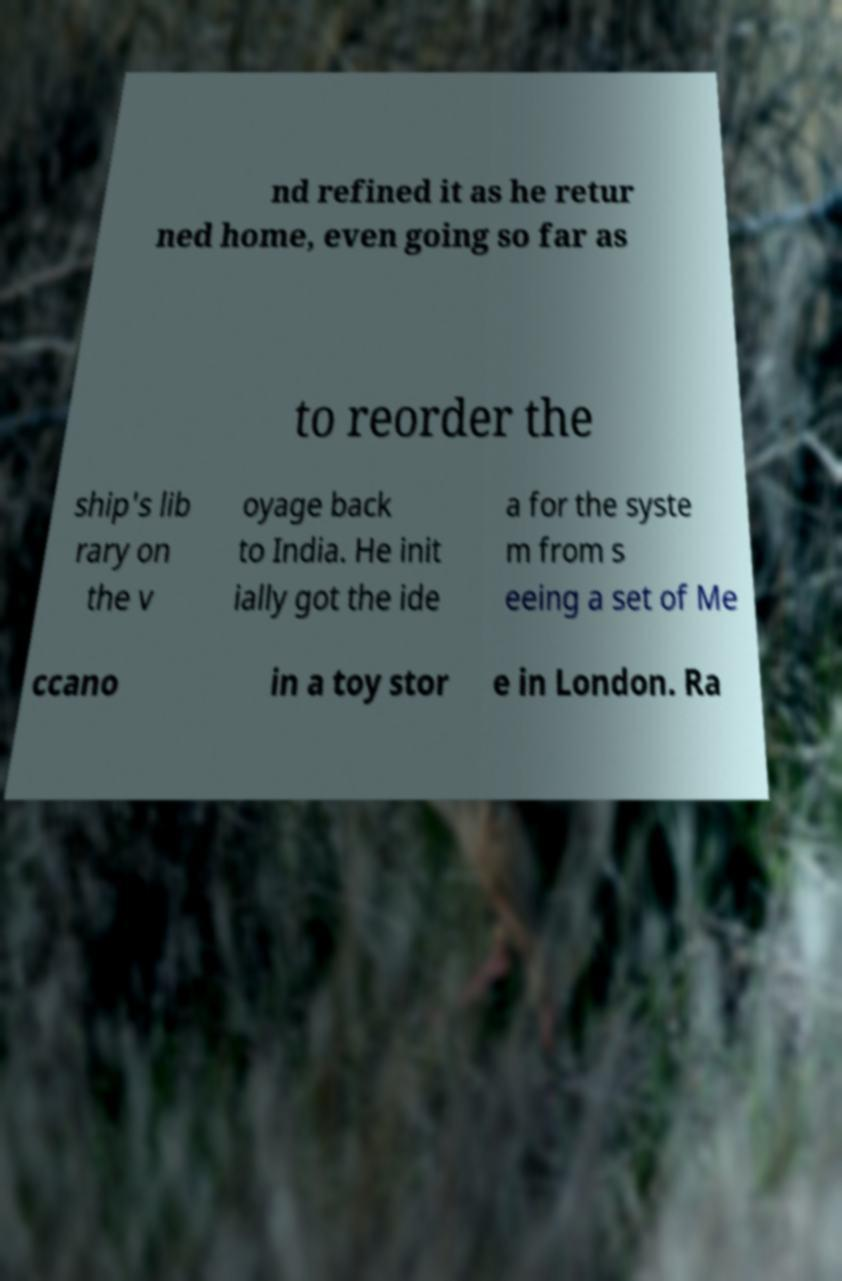Could you assist in decoding the text presented in this image and type it out clearly? nd refined it as he retur ned home, even going so far as to reorder the ship's lib rary on the v oyage back to India. He init ially got the ide a for the syste m from s eeing a set of Me ccano in a toy stor e in London. Ra 